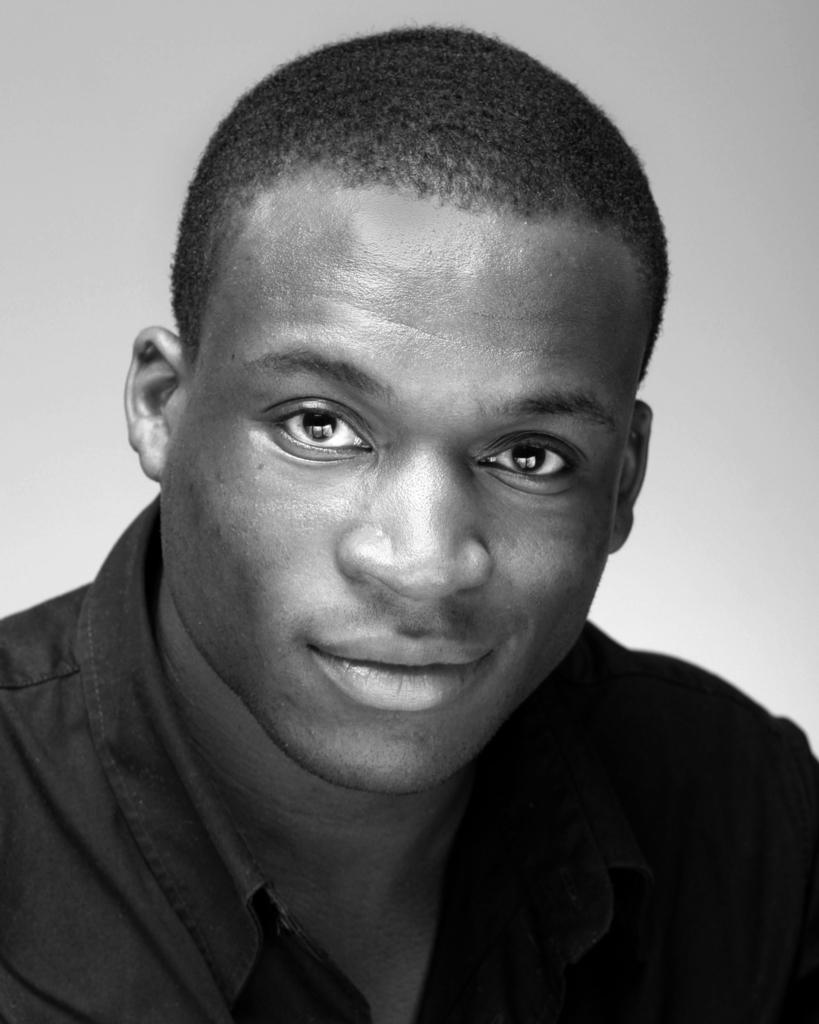What is the color scheme of the image? The image is black and white. Who is present in the image? There is a man in the image. What is the man wearing? The man is wearing a shirt. What can be seen behind the man in the image? The background of the image is plain. What type of note is the man holding in the image? There is no note present in the image; the man is not holding anything. What is the ground like in the image? The ground is not visible in the image, as it only shows the man and the plain background. 